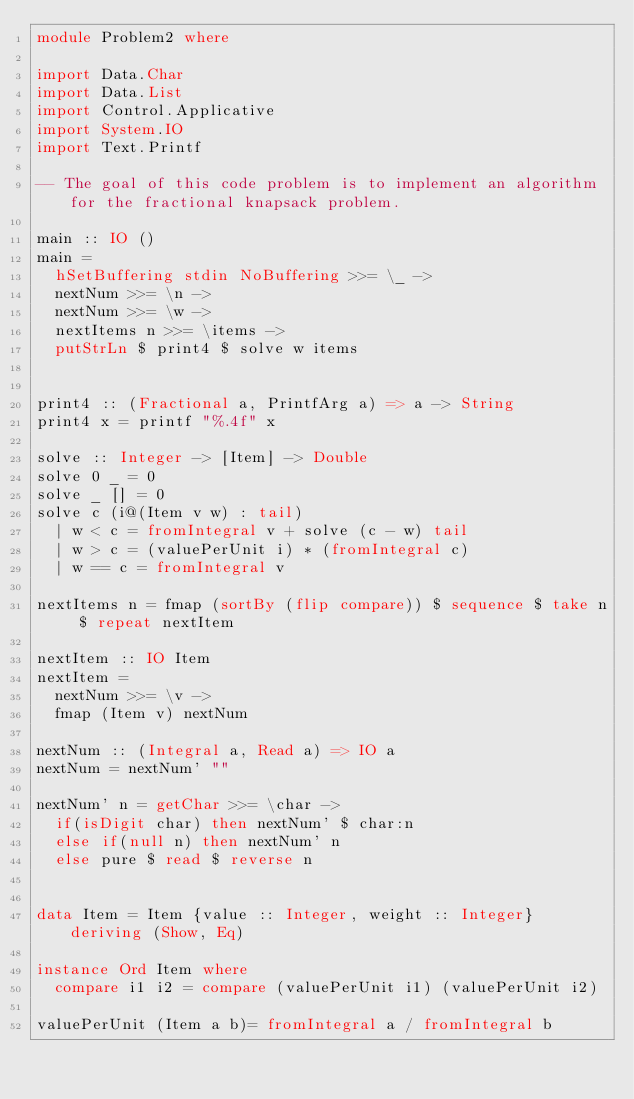Convert code to text. <code><loc_0><loc_0><loc_500><loc_500><_Haskell_>module Problem2 where

import Data.Char
import Data.List
import Control.Applicative
import System.IO
import Text.Printf

-- The goal of this code problem is to implement an algorithm for the fractional knapsack problem.

main :: IO ()
main =
  hSetBuffering stdin NoBuffering >>= \_ ->
  nextNum >>= \n ->
  nextNum >>= \w ->
  nextItems n >>= \items ->
  putStrLn $ print4 $ solve w items


print4 :: (Fractional a, PrintfArg a) => a -> String
print4 x = printf "%.4f" x

solve :: Integer -> [Item] -> Double
solve 0 _ = 0
solve _ [] = 0
solve c (i@(Item v w) : tail)
  | w < c = fromIntegral v + solve (c - w) tail
  | w > c = (valuePerUnit i) * (fromIntegral c)
  | w == c = fromIntegral v

nextItems n = fmap (sortBy (flip compare)) $ sequence $ take n $ repeat nextItem

nextItem :: IO Item
nextItem =
  nextNum >>= \v ->
  fmap (Item v) nextNum

nextNum :: (Integral a, Read a) => IO a
nextNum = nextNum' ""

nextNum' n = getChar >>= \char ->
  if(isDigit char) then nextNum' $ char:n
  else if(null n) then nextNum' n
  else pure $ read $ reverse n


data Item = Item {value :: Integer, weight :: Integer} deriving (Show, Eq)

instance Ord Item where
  compare i1 i2 = compare (valuePerUnit i1) (valuePerUnit i2)

valuePerUnit (Item a b)= fromIntegral a / fromIntegral b
</code> 